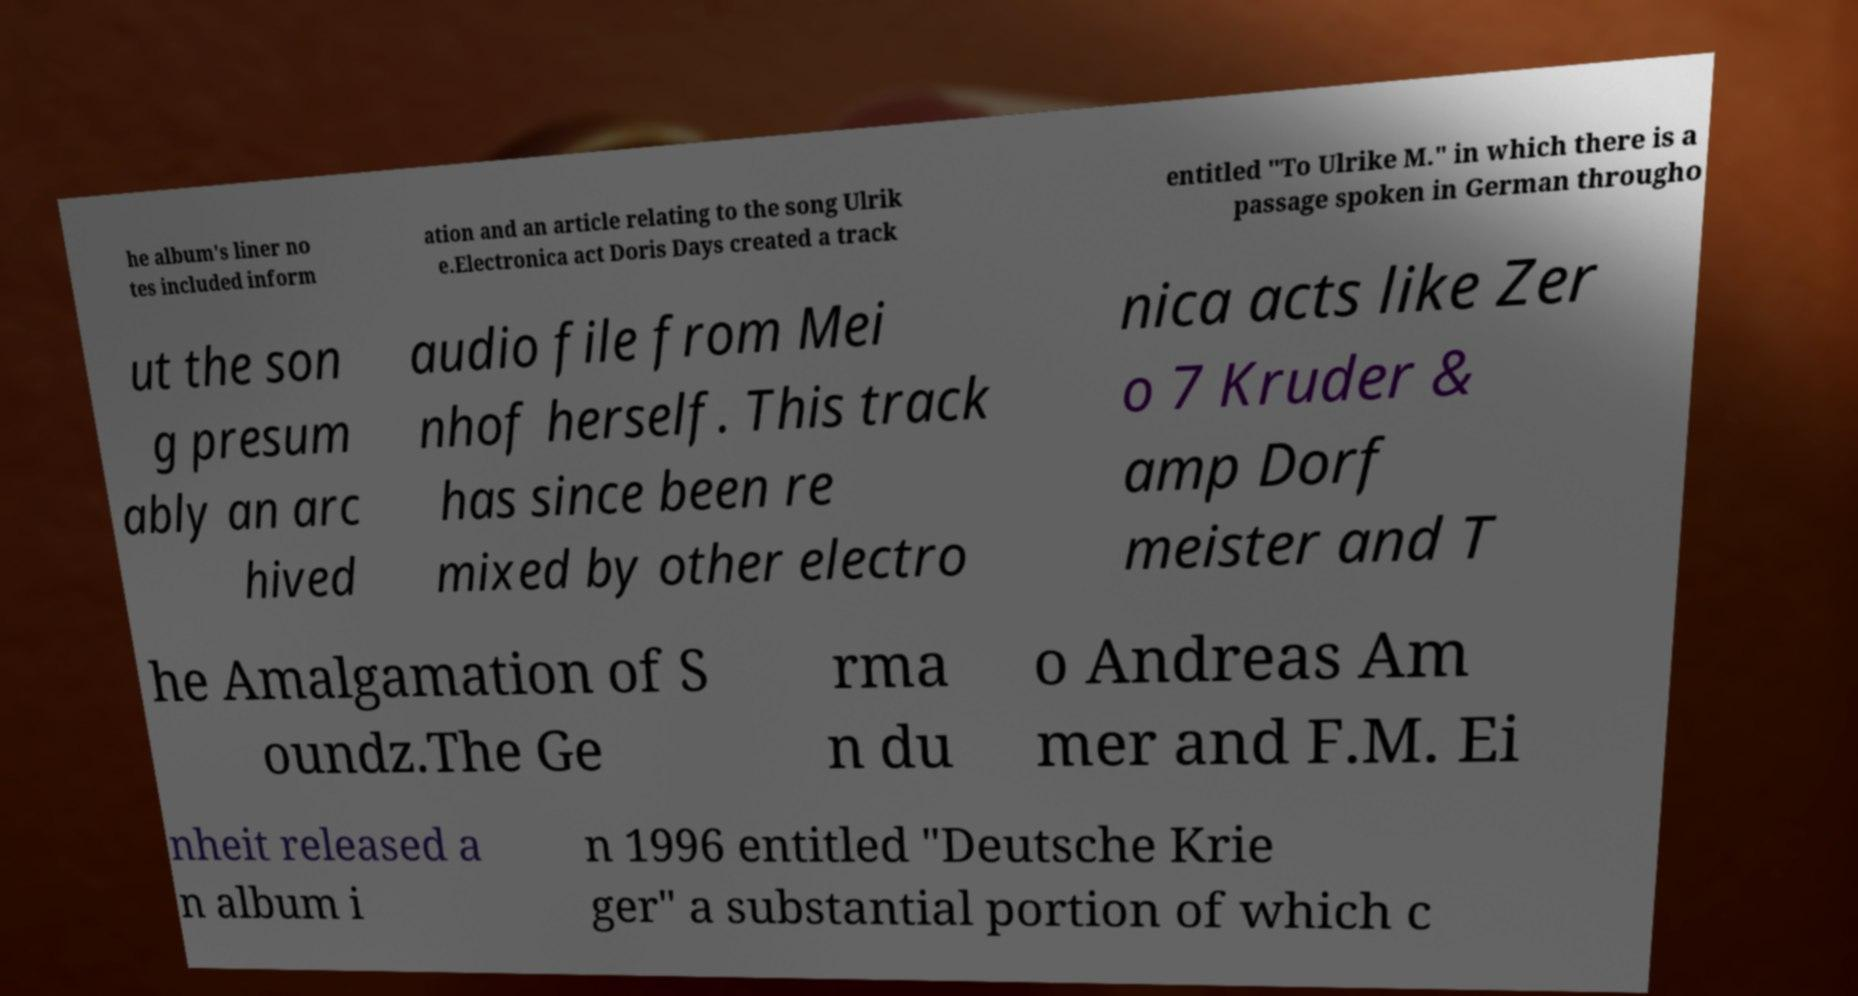Could you assist in decoding the text presented in this image and type it out clearly? he album's liner no tes included inform ation and an article relating to the song Ulrik e.Electronica act Doris Days created a track entitled "To Ulrike M." in which there is a passage spoken in German througho ut the son g presum ably an arc hived audio file from Mei nhof herself. This track has since been re mixed by other electro nica acts like Zer o 7 Kruder & amp Dorf meister and T he Amalgamation of S oundz.The Ge rma n du o Andreas Am mer and F.M. Ei nheit released a n album i n 1996 entitled "Deutsche Krie ger" a substantial portion of which c 